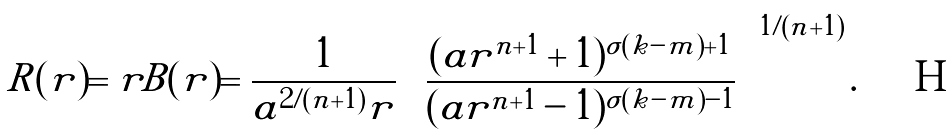Convert formula to latex. <formula><loc_0><loc_0><loc_500><loc_500>R ( r ) = r B ( r ) = \frac { 1 } { a ^ { 2 / ( n + 1 ) } r } \left [ \frac { ( a r ^ { n + 1 } + 1 ) ^ { \sigma ( k - m ) + 1 } } { ( a r ^ { n + 1 } - 1 ) ^ { \sigma ( k - m ) - 1 } } \right ] ^ { 1 / ( n + 1 ) } .</formula> 